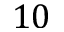Convert formula to latex. <formula><loc_0><loc_0><loc_500><loc_500>1 0</formula> 